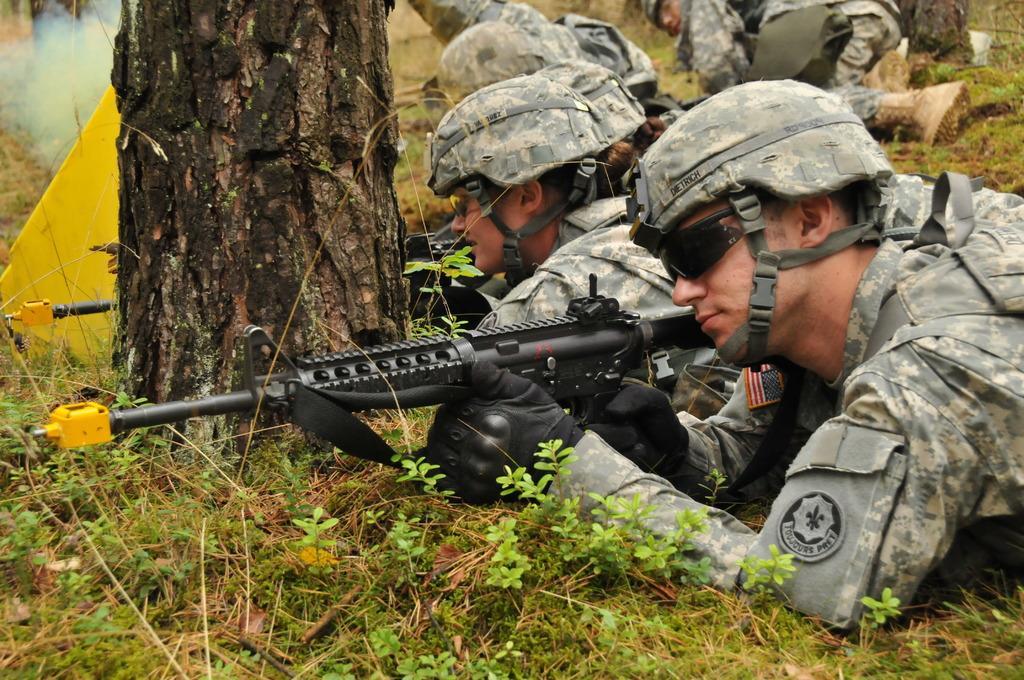Can you describe this image briefly? In this picture I can see some army people laying on the grass and holding guns, side there is a stem of a tree. 